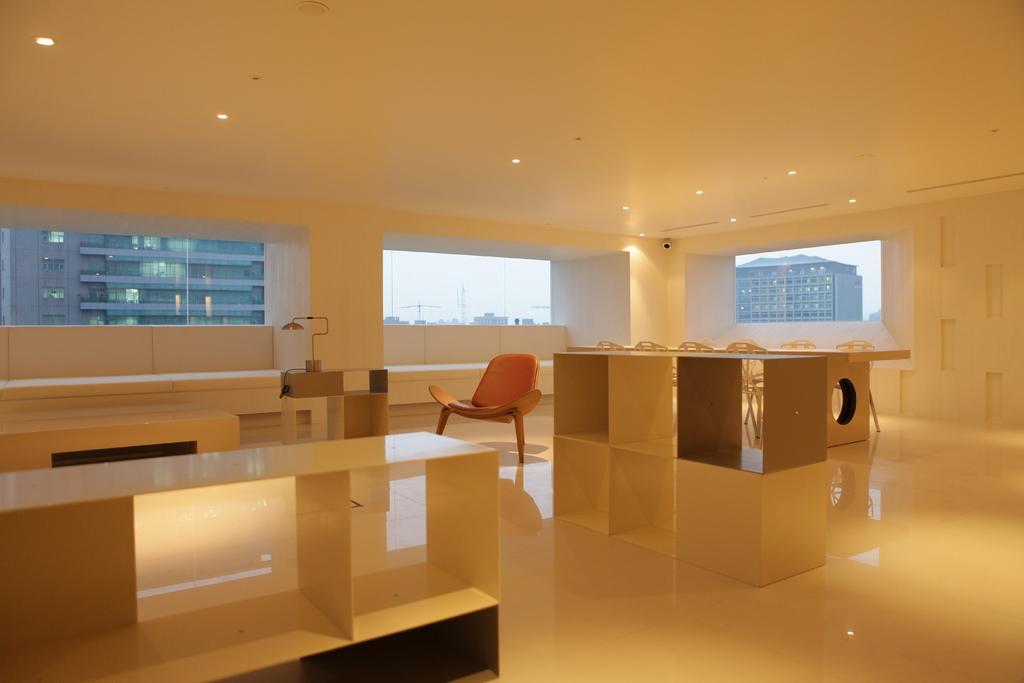Describe this image in one or two sentences. In this picture we can see inside of the building. We can see chairs, tables, floor and windows, through windows we can see buildings, poles and sky. At the top we can see lights. 